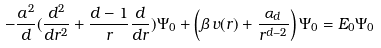Convert formula to latex. <formula><loc_0><loc_0><loc_500><loc_500>- \frac { a ^ { 2 } } { d } ( \frac { d ^ { 2 } } { d r ^ { 2 } } + \frac { d - 1 } { r } \frac { d } { d r } ) \Psi _ { 0 } + \left ( \beta \, v ( r ) + \frac { \alpha _ { d } } { r ^ { d - 2 } } \right ) \Psi _ { 0 } = E _ { 0 } \Psi _ { 0 }</formula> 